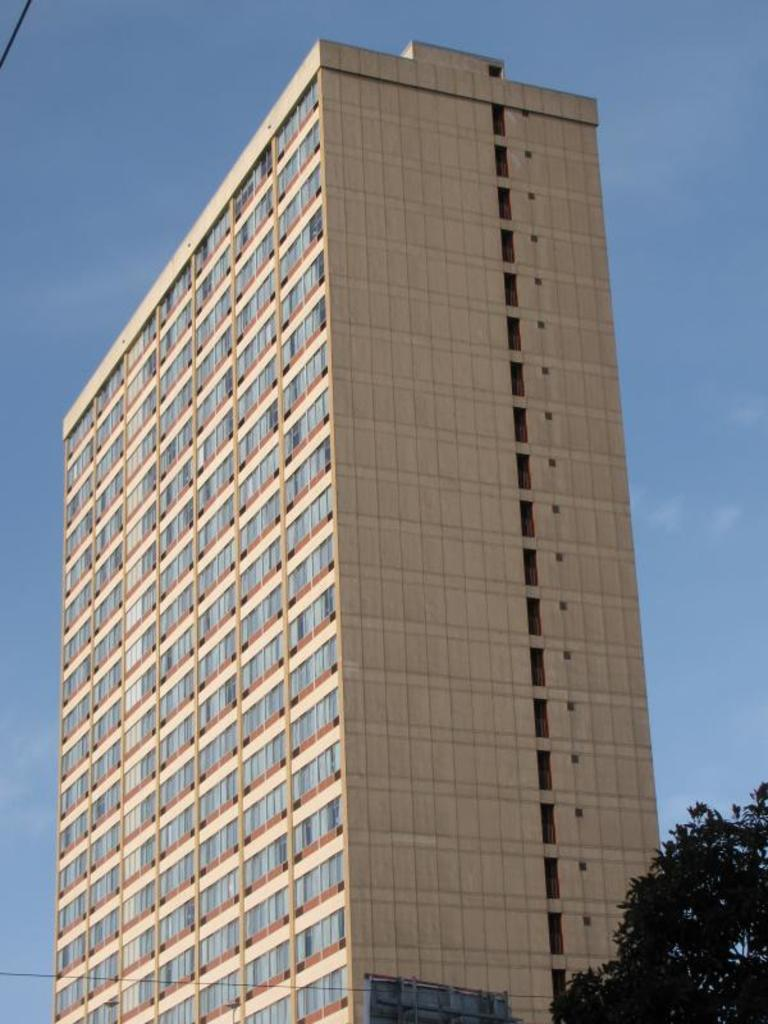What structure can be seen in the image? There is a building in the image. Is there any vegetation visible near the building? Yes, there is a tree beside the building in the image. Can you see the son playing near the building in the image? There is no son present in the image. What type of waves can be seen crashing against the building in the image? There are no waves present in the image, as it features a building and a tree. 